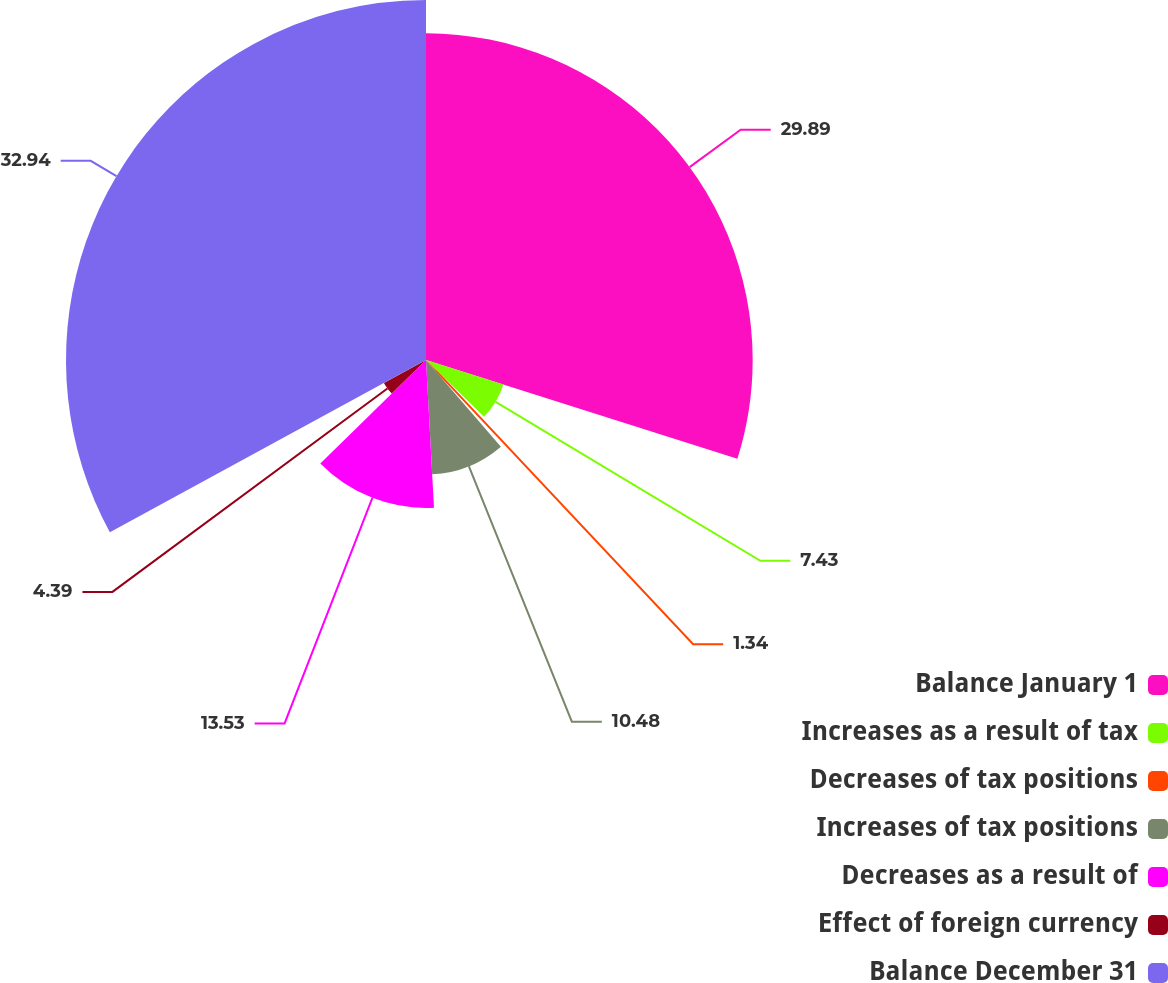Convert chart to OTSL. <chart><loc_0><loc_0><loc_500><loc_500><pie_chart><fcel>Balance January 1<fcel>Increases as a result of tax<fcel>Decreases of tax positions<fcel>Increases of tax positions<fcel>Decreases as a result of<fcel>Effect of foreign currency<fcel>Balance December 31<nl><fcel>29.89%<fcel>7.43%<fcel>1.34%<fcel>10.48%<fcel>13.53%<fcel>4.39%<fcel>32.94%<nl></chart> 